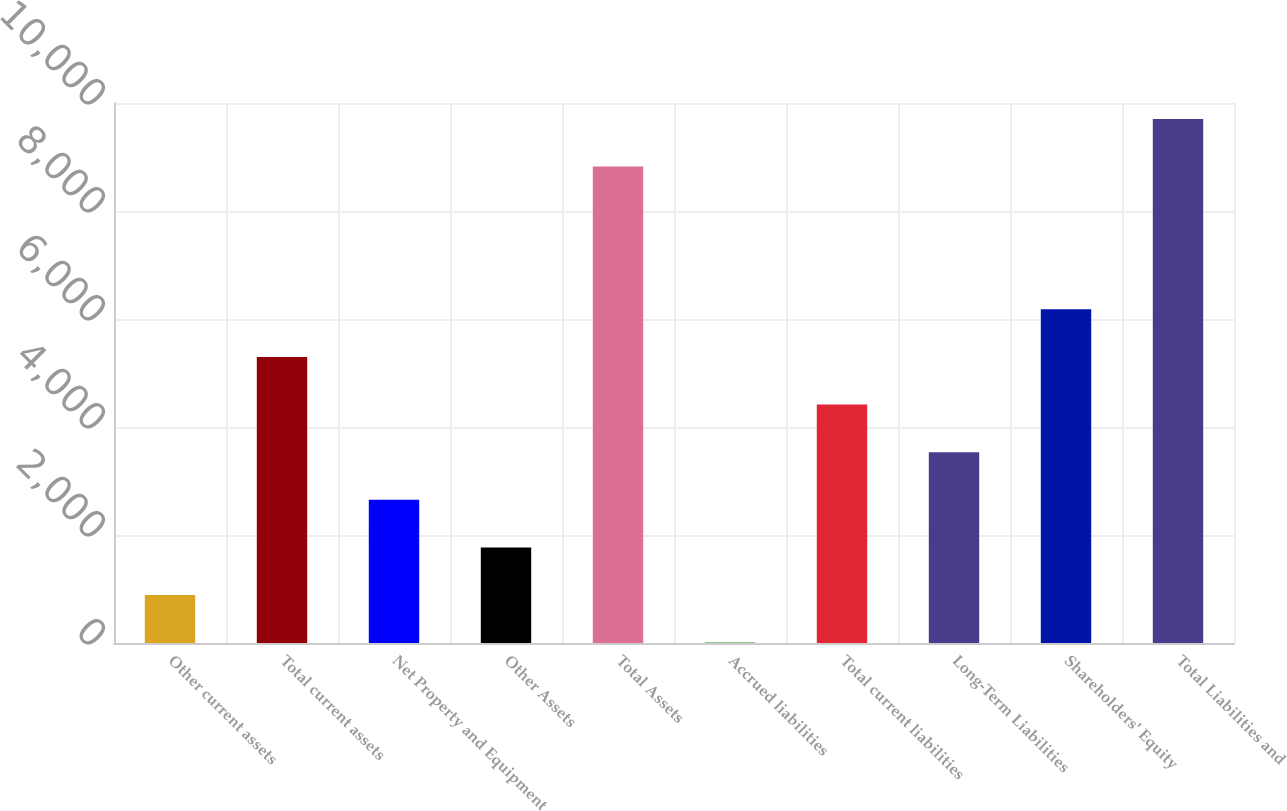<chart> <loc_0><loc_0><loc_500><loc_500><bar_chart><fcel>Other current assets<fcel>Total current assets<fcel>Net Property and Equipment<fcel>Other Assets<fcel>Total Assets<fcel>Accrued liabilities<fcel>Total current liabilities<fcel>Long-Term Liabilities<fcel>Shareholders' Equity<fcel>Total Liabilities and<nl><fcel>888.7<fcel>5297.2<fcel>2652.1<fcel>1770.4<fcel>8824<fcel>7<fcel>4415.5<fcel>3533.8<fcel>6178.9<fcel>9705.7<nl></chart> 